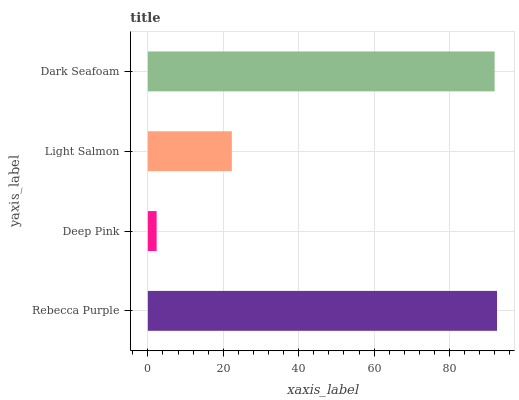Is Deep Pink the minimum?
Answer yes or no. Yes. Is Rebecca Purple the maximum?
Answer yes or no. Yes. Is Light Salmon the minimum?
Answer yes or no. No. Is Light Salmon the maximum?
Answer yes or no. No. Is Light Salmon greater than Deep Pink?
Answer yes or no. Yes. Is Deep Pink less than Light Salmon?
Answer yes or no. Yes. Is Deep Pink greater than Light Salmon?
Answer yes or no. No. Is Light Salmon less than Deep Pink?
Answer yes or no. No. Is Dark Seafoam the high median?
Answer yes or no. Yes. Is Light Salmon the low median?
Answer yes or no. Yes. Is Rebecca Purple the high median?
Answer yes or no. No. Is Dark Seafoam the low median?
Answer yes or no. No. 